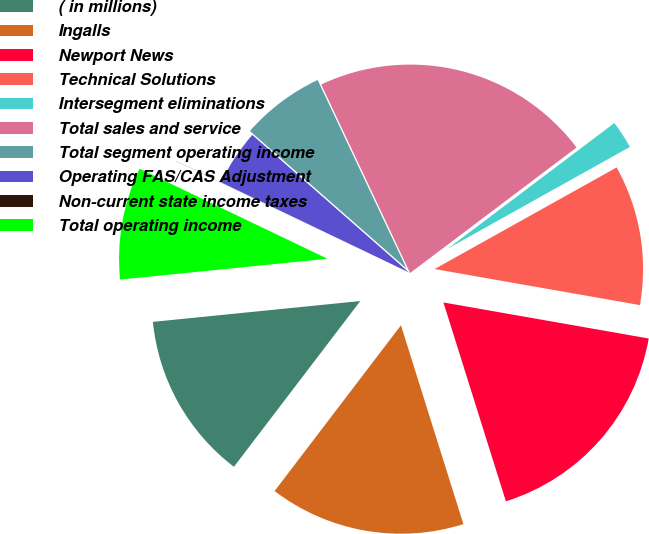<chart> <loc_0><loc_0><loc_500><loc_500><pie_chart><fcel>( in millions)<fcel>Ingalls<fcel>Newport News<fcel>Technical Solutions<fcel>Intersegment eliminations<fcel>Total sales and service<fcel>Total segment operating income<fcel>Operating FAS/CAS Adjustment<fcel>Non-current state income taxes<fcel>Total operating income<nl><fcel>13.04%<fcel>15.21%<fcel>17.39%<fcel>10.87%<fcel>2.18%<fcel>21.73%<fcel>6.52%<fcel>4.35%<fcel>0.01%<fcel>8.7%<nl></chart> 